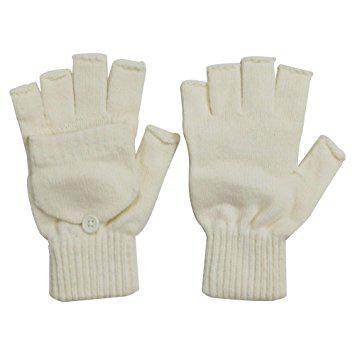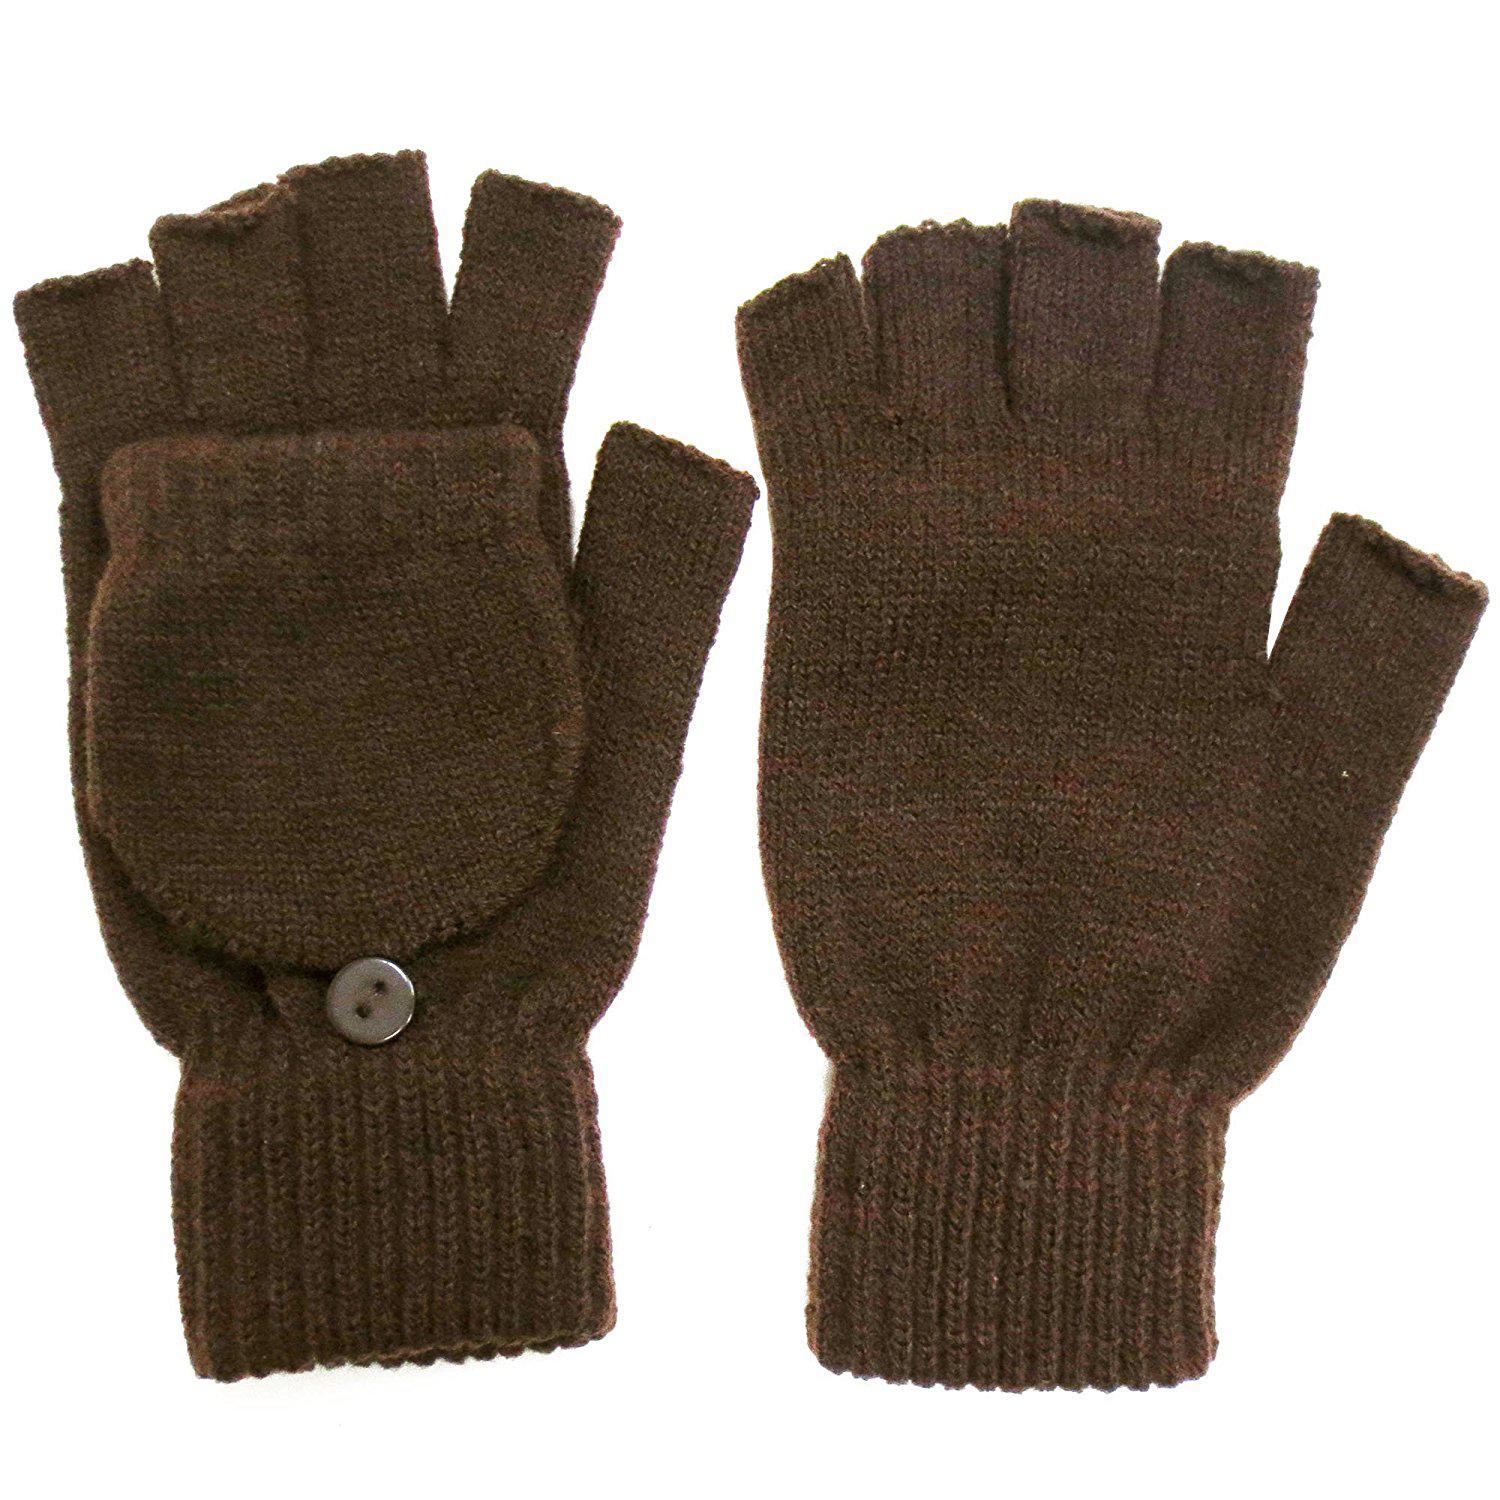The first image is the image on the left, the second image is the image on the right. Assess this claim about the two images: "the gloves on the right don't have cut off fingers". Correct or not? Answer yes or no. No. The first image is the image on the left, the second image is the image on the right. Examine the images to the left and right. Is the description "Both gloves have detachable fingers" accurate? Answer yes or no. Yes. 